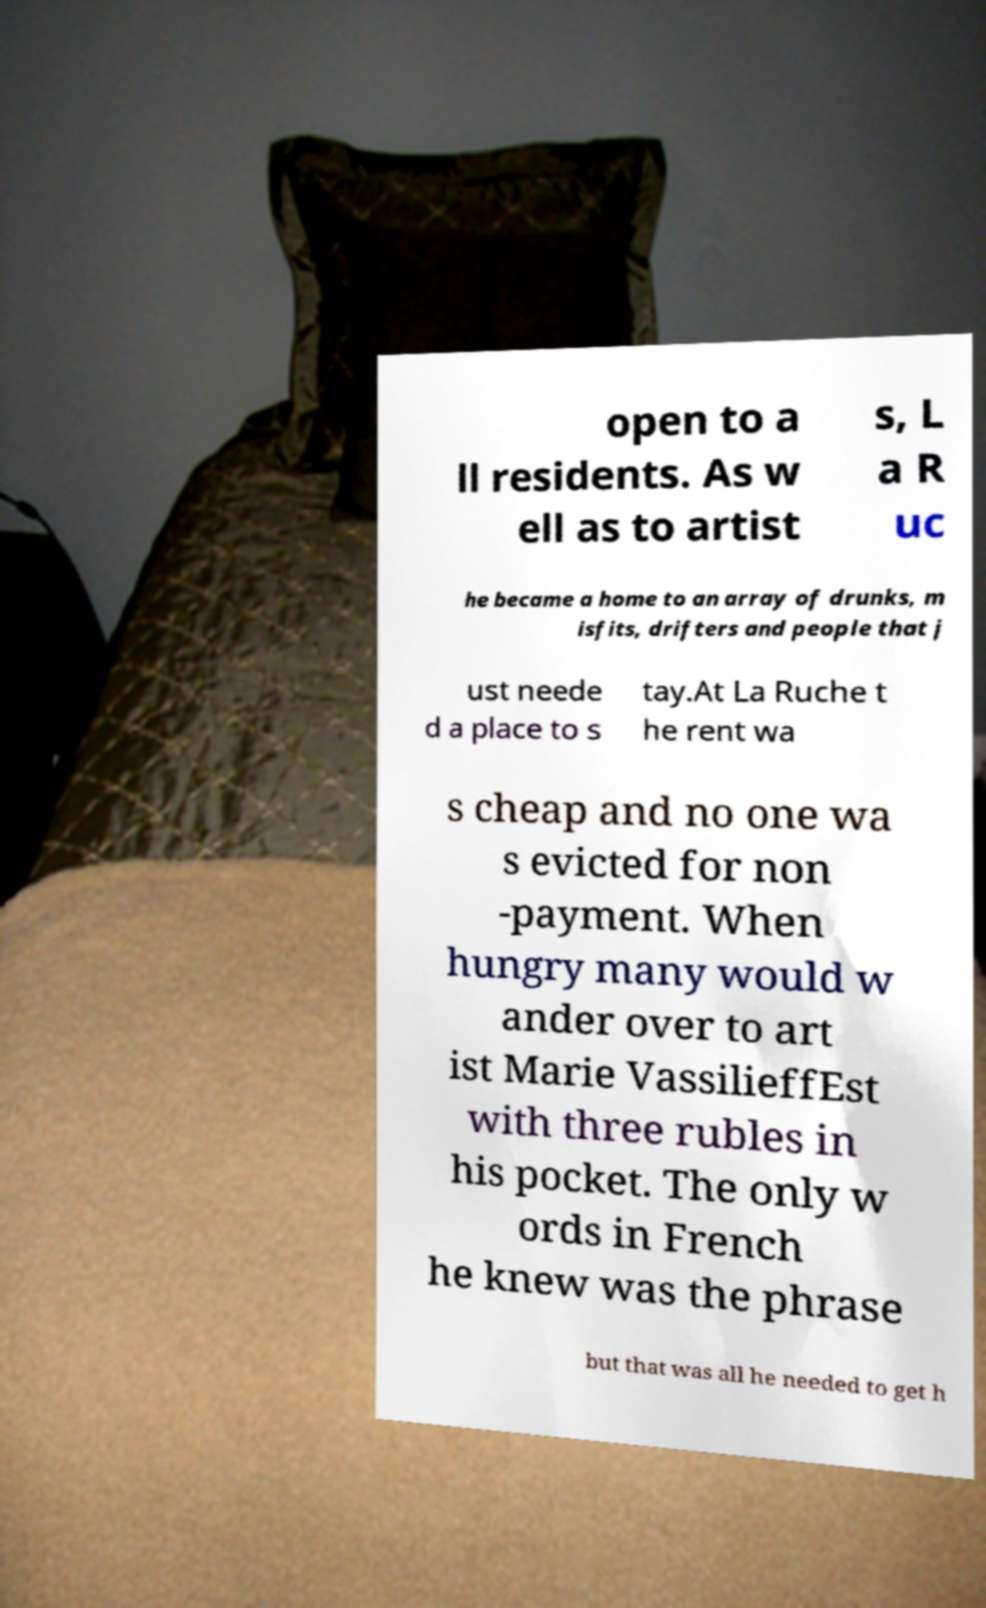For documentation purposes, I need the text within this image transcribed. Could you provide that? open to a ll residents. As w ell as to artist s, L a R uc he became a home to an array of drunks, m isfits, drifters and people that j ust neede d a place to s tay.At La Ruche t he rent wa s cheap and no one wa s evicted for non -payment. When hungry many would w ander over to art ist Marie VassilieffEst with three rubles in his pocket. The only w ords in French he knew was the phrase but that was all he needed to get h 